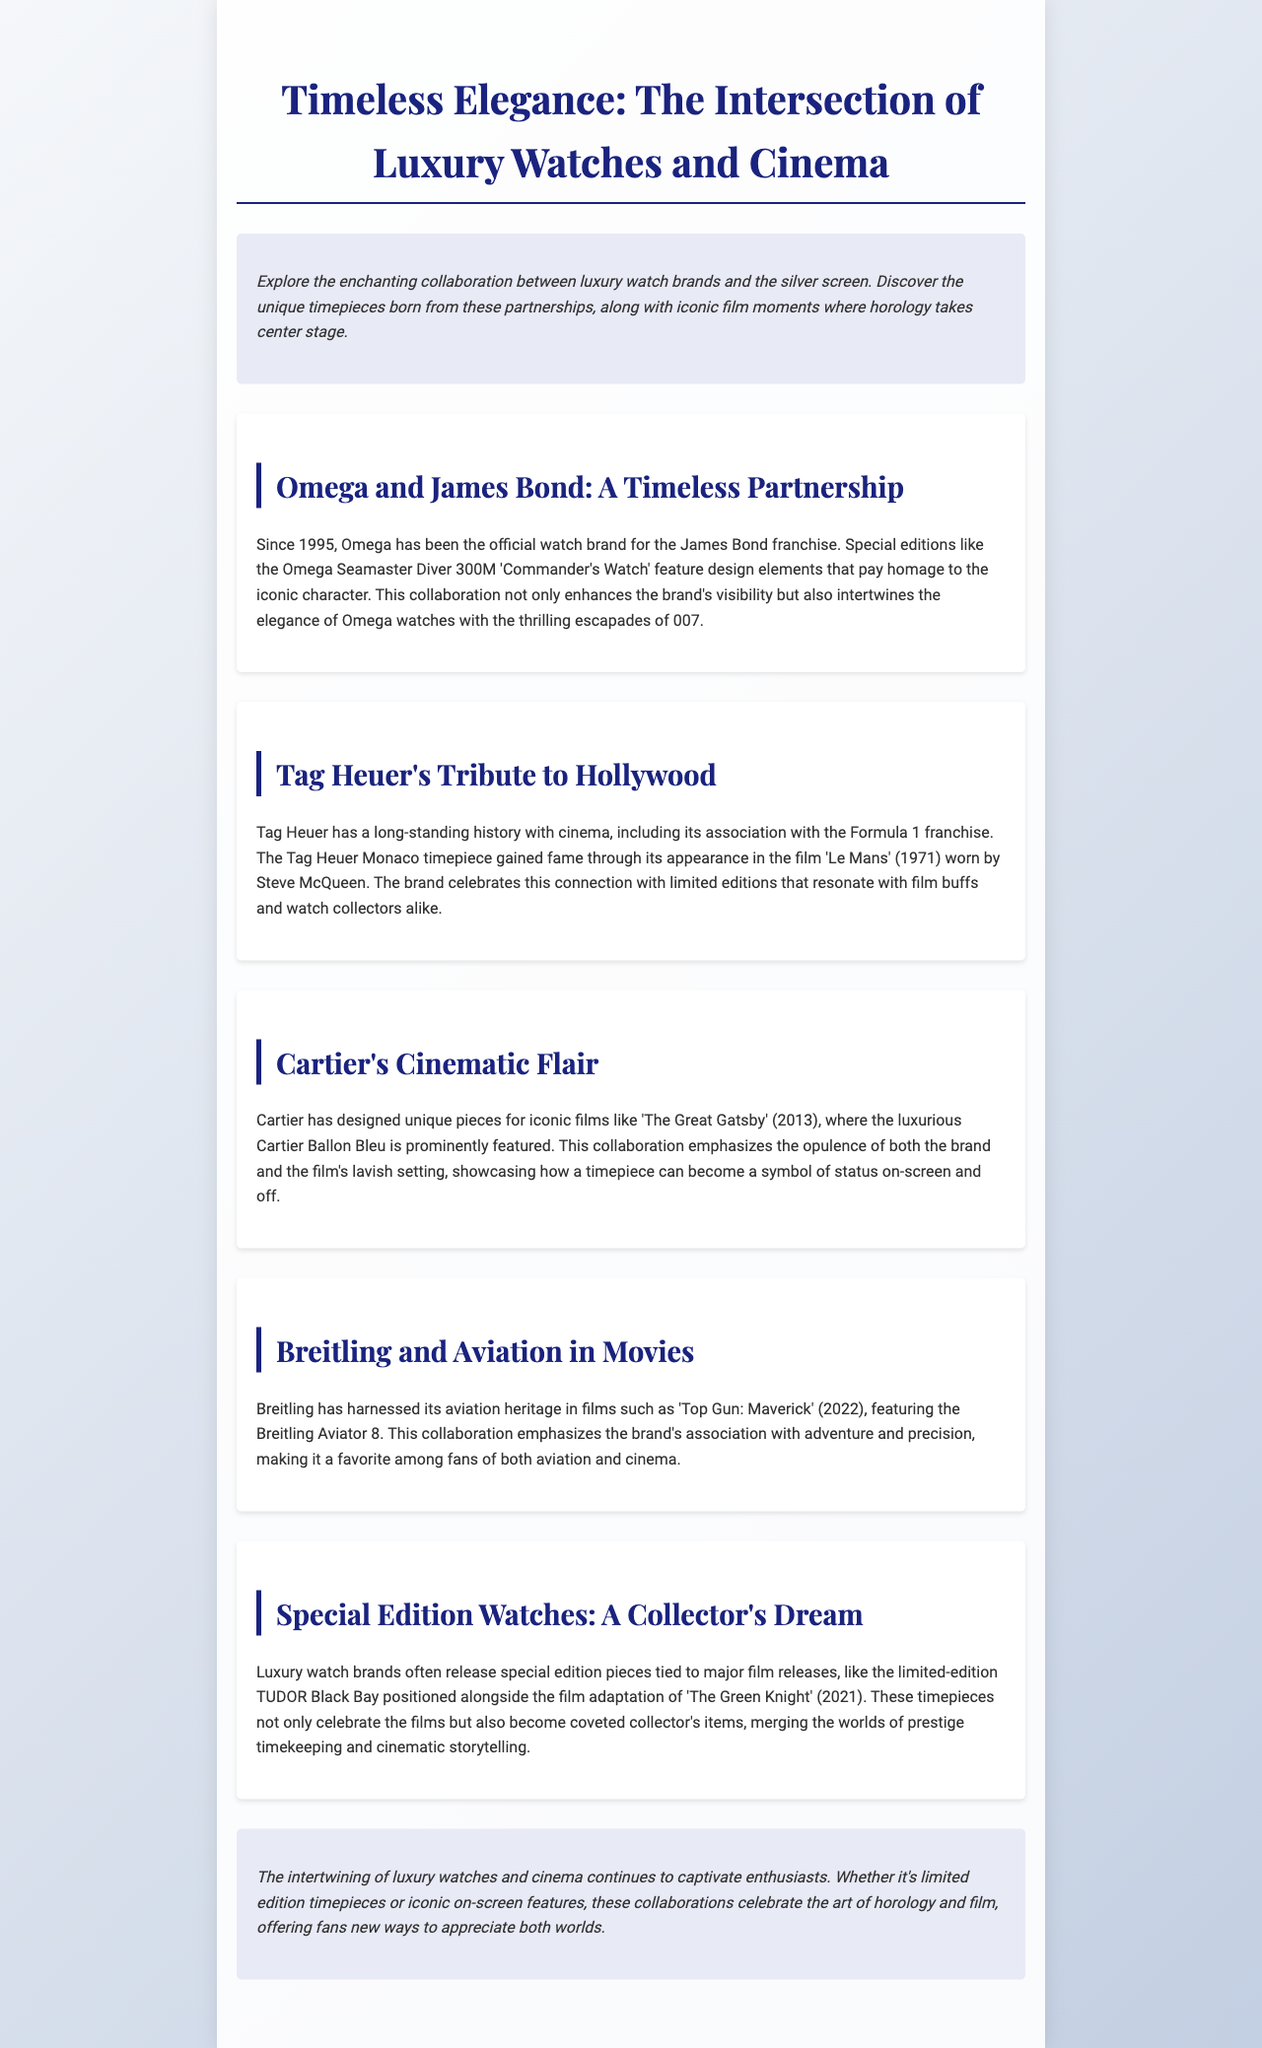What year did Omega become the official watch brand for James Bond? Omega has been the official watch brand for the James Bond franchise since 1995, as stated in the document.
Answer: 1995 Which watch brand is associated with the film 'Le Mans'? The document mentions Tag Heuer's connection to the film 'Le Mans', highlighting the Tag Heuer Monaco timepiece worn by Steve McQueen.
Answer: Tag Heuer What is the name of the Cartier timepiece featured in 'The Great Gatsby'? The document specifies the Cartier Ballon Bleu as a luxurious timepiece featured in 'The Great Gatsby' (2013).
Answer: Cartier Ballon Bleu Which film showcases the Breitling Aviator 8? The document states that Breitling's Aviator 8 was featured in 'Top Gun: Maverick' (2022).
Answer: Top Gun: Maverick What is the special edition watch mentioned in connection with 'The Green Knight'? The document highlights the limited-edition TUDOR Black Bay in relation to the film adaptation of 'The Green Knight' (2021).
Answer: TUDOR Black Bay How do special edition watches benefit collectors? The document explains that special edition timepieces become coveted collector's items, thus merging prestige timekeeping and cinematic storytelling.
Answer: Coveted collector's items What theme connects luxury watches and cinema according to the closing paragraph? The closing paragraph emphasizes the captivating intertwining of luxury watches and cinema, illustrating their connection in unique collaborations.
Answer: Intertwining of luxury watches and cinema What genre of films does Breitling primarily relate to? The document indicates that Breitling has a strong association with aviation-themed films like 'Top Gun: Maverick'.
Answer: Aviation What is the overall purpose of the newsletter? The newsletter aims to showcase the enchanting collaboration between luxury watch brands and cinema, highlighting unique timepieces and iconic film moments.
Answer: Showcase collaboration 